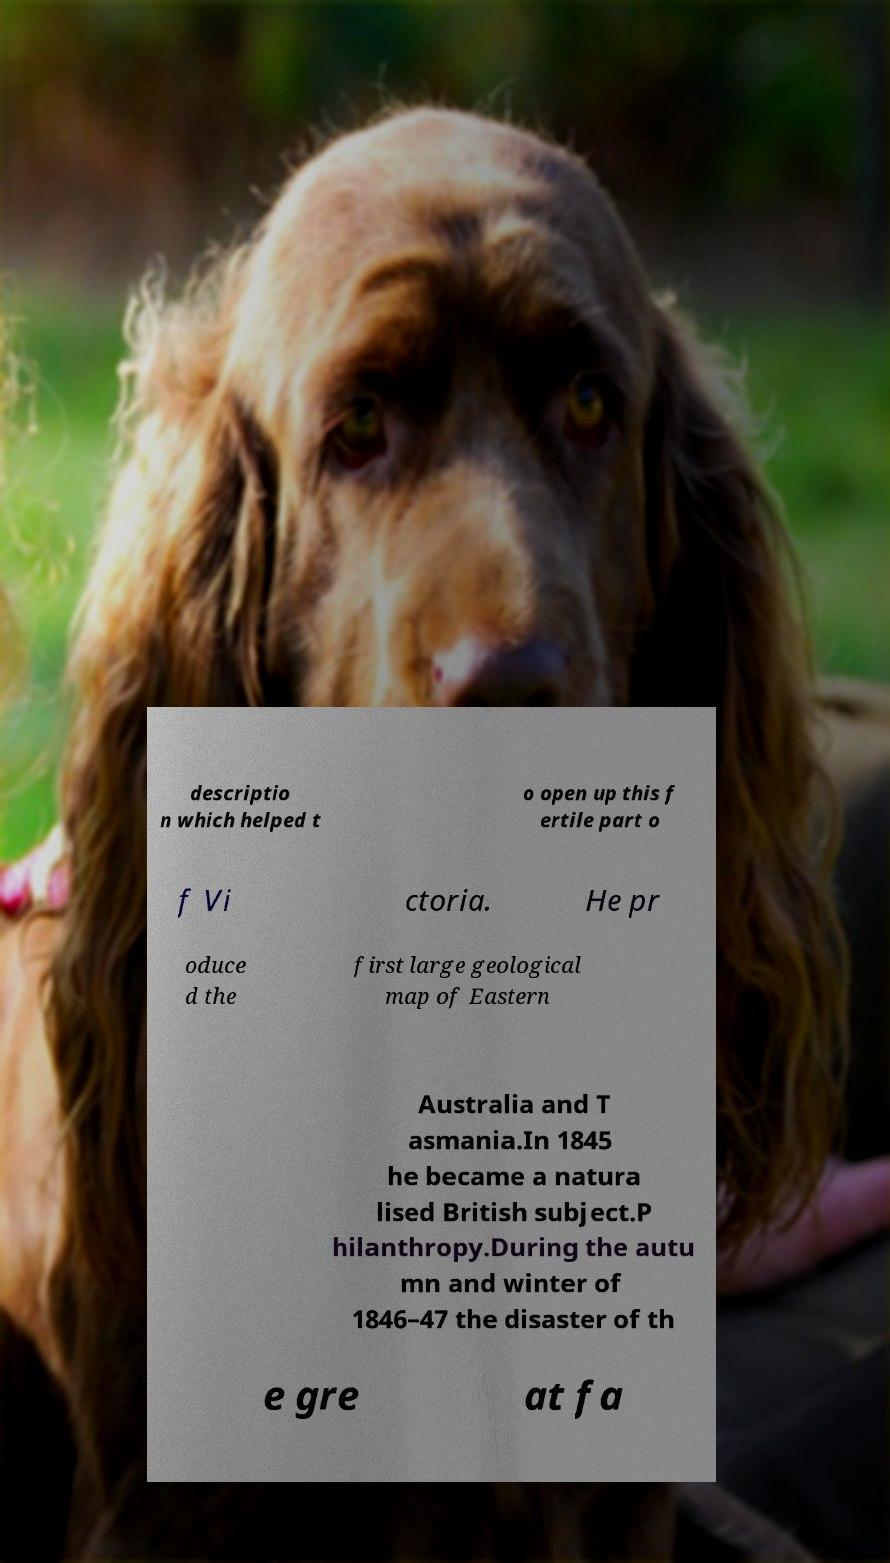For documentation purposes, I need the text within this image transcribed. Could you provide that? descriptio n which helped t o open up this f ertile part o f Vi ctoria. He pr oduce d the first large geological map of Eastern Australia and T asmania.In 1845 he became a natura lised British subject.P hilanthropy.During the autu mn and winter of 1846–47 the disaster of th e gre at fa 